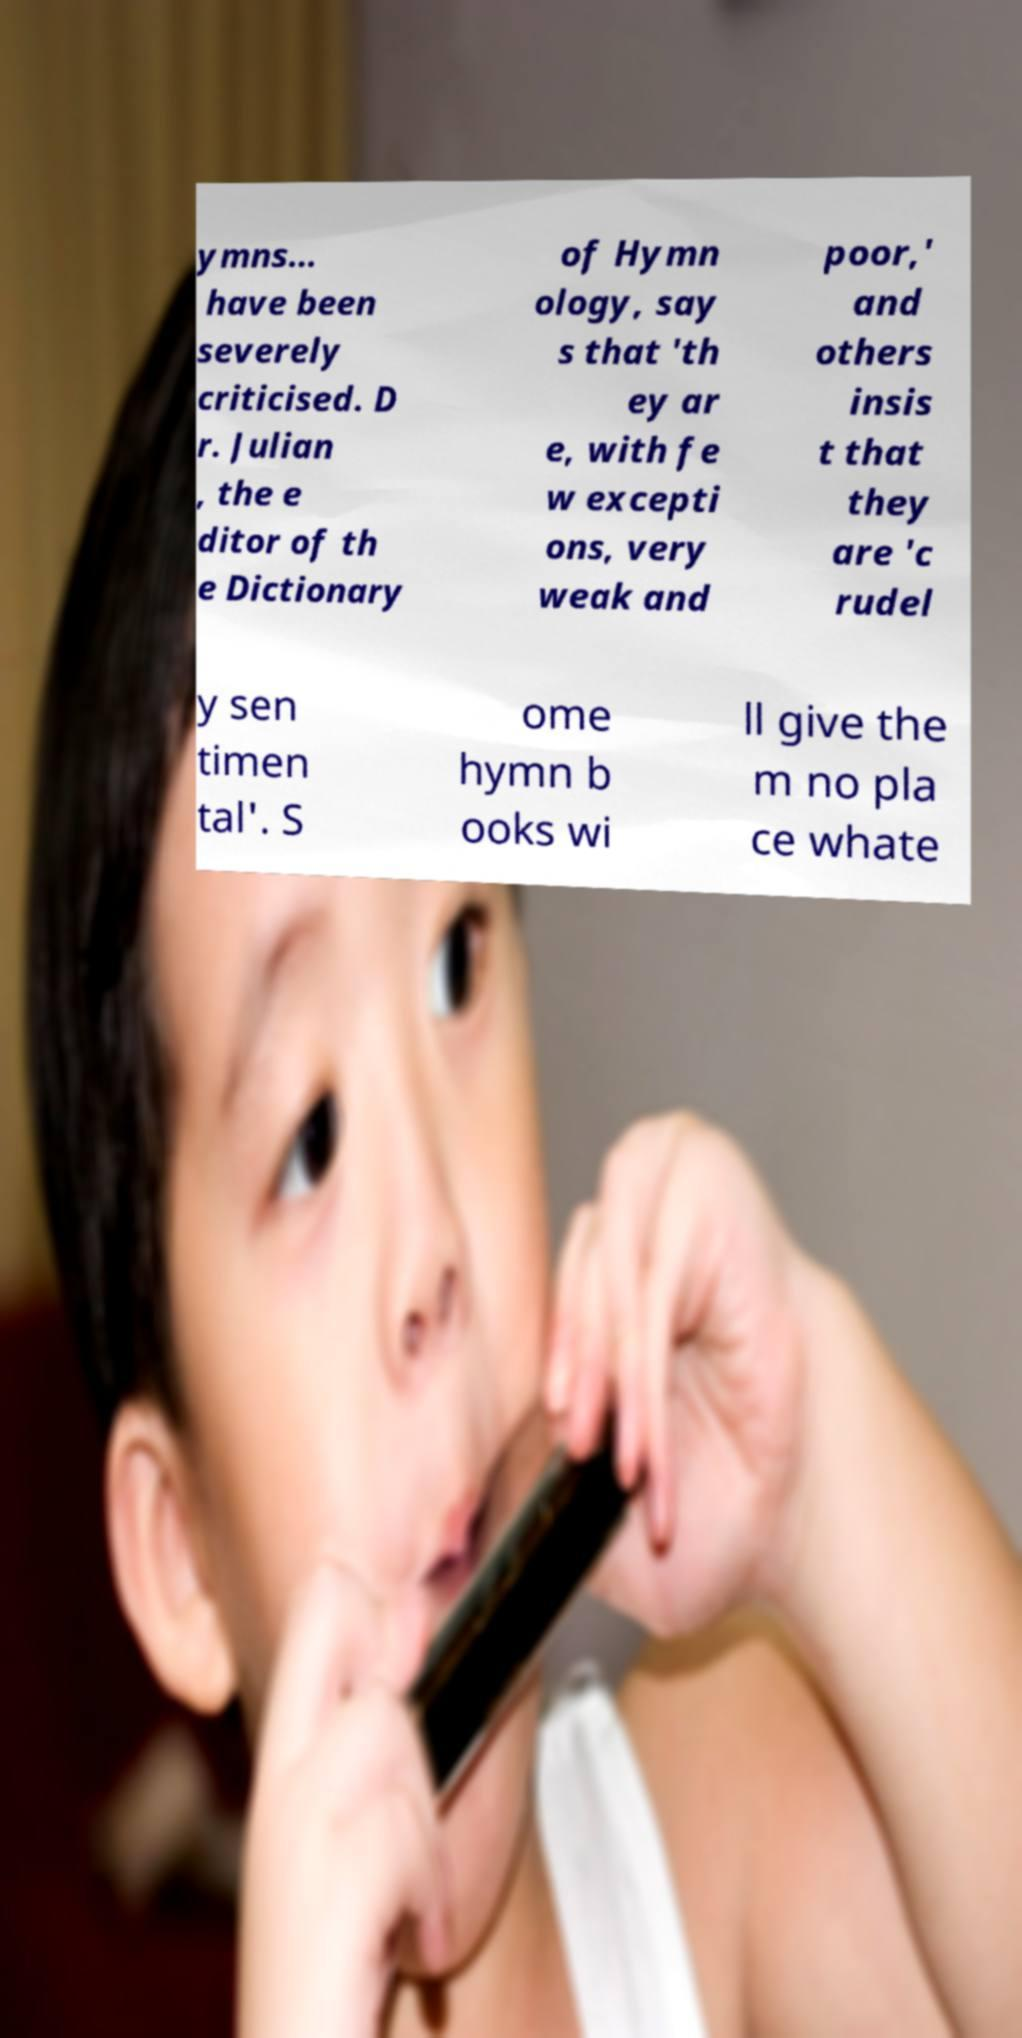Could you assist in decoding the text presented in this image and type it out clearly? ymns... have been severely criticised. D r. Julian , the e ditor of th e Dictionary of Hymn ology, say s that 'th ey ar e, with fe w excepti ons, very weak and poor,' and others insis t that they are 'c rudel y sen timen tal'. S ome hymn b ooks wi ll give the m no pla ce whate 